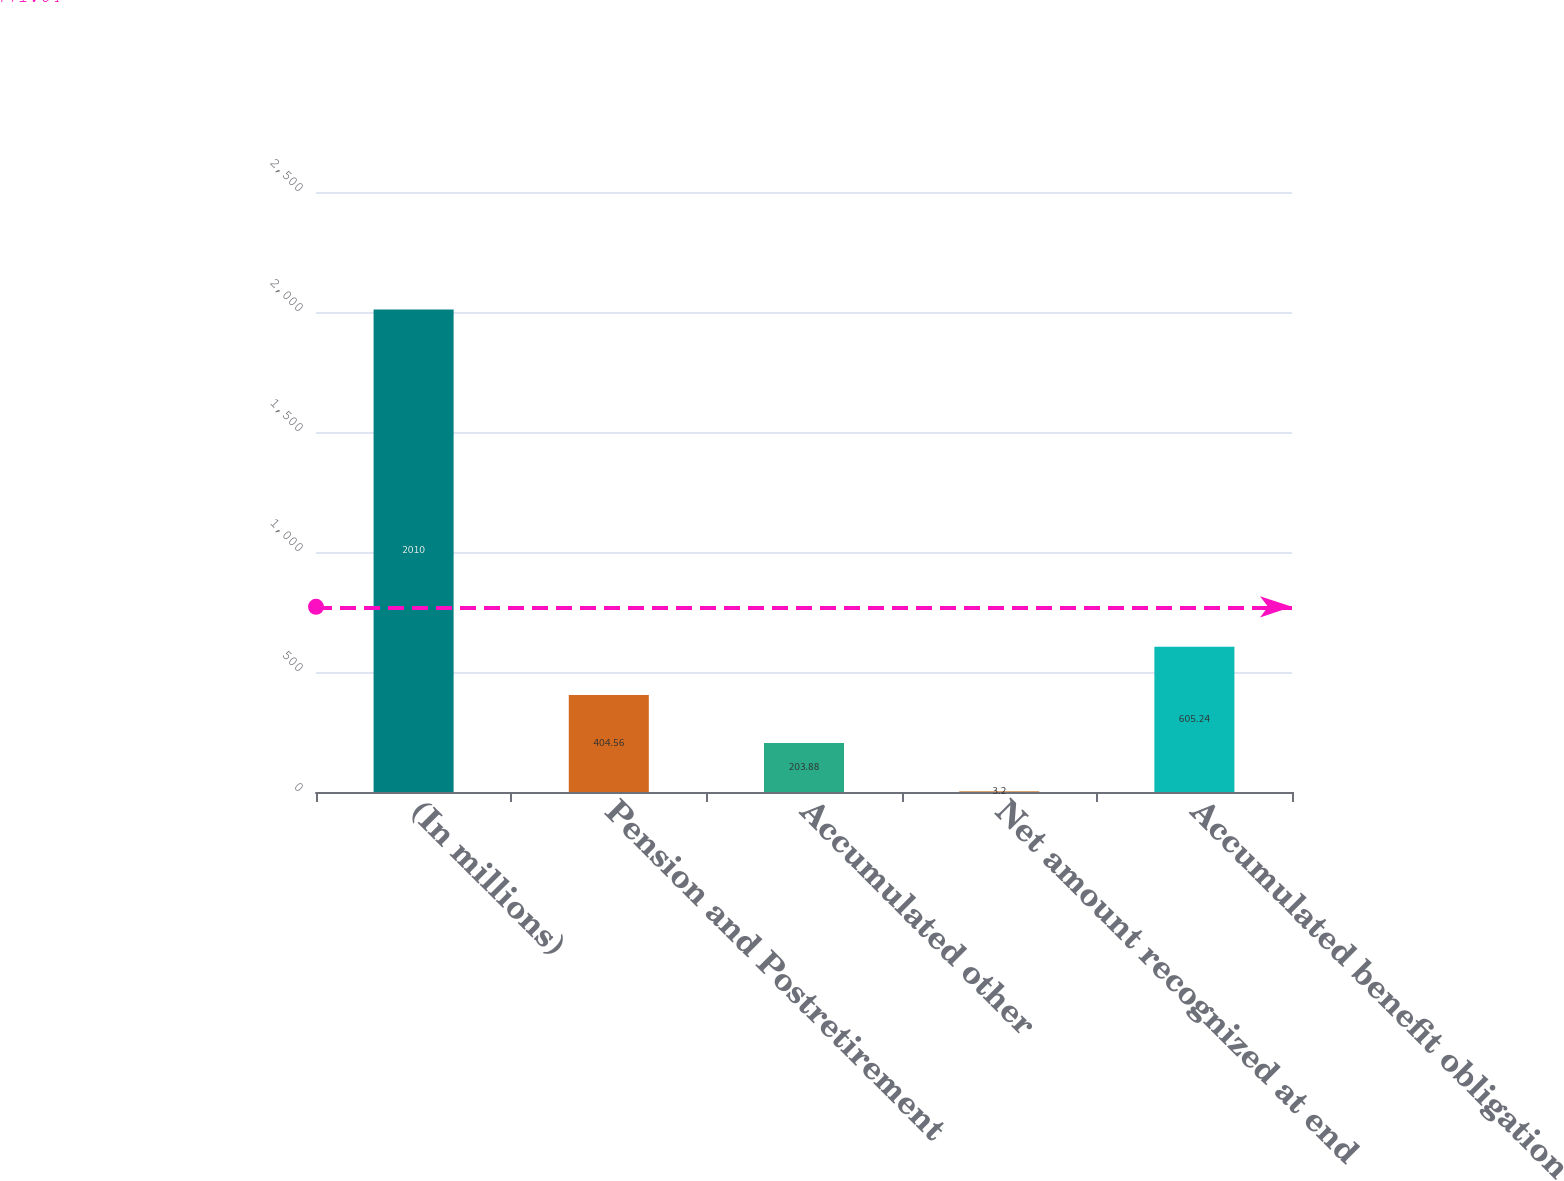<chart> <loc_0><loc_0><loc_500><loc_500><bar_chart><fcel>(In millions)<fcel>Pension and Postretirement<fcel>Accumulated other<fcel>Net amount recognized at end<fcel>Accumulated benefit obligation<nl><fcel>2010<fcel>404.56<fcel>203.88<fcel>3.2<fcel>605.24<nl></chart> 